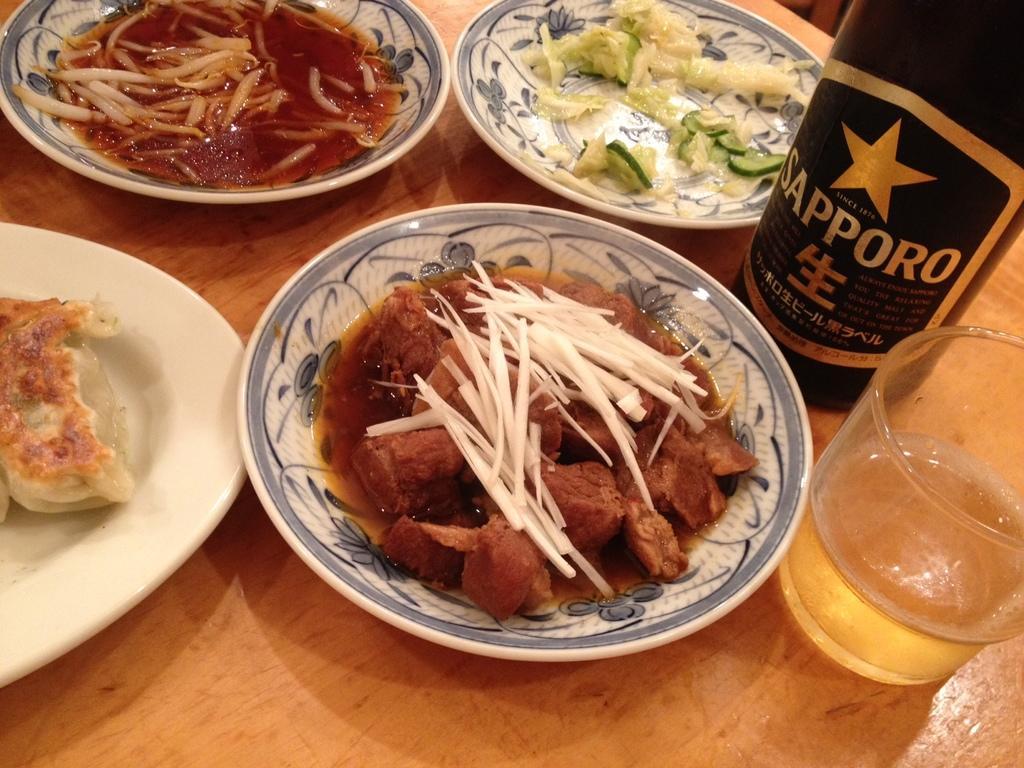In one or two sentences, can you explain what this image depicts? On this wooden table we can see plates, bottles, glass and food. 